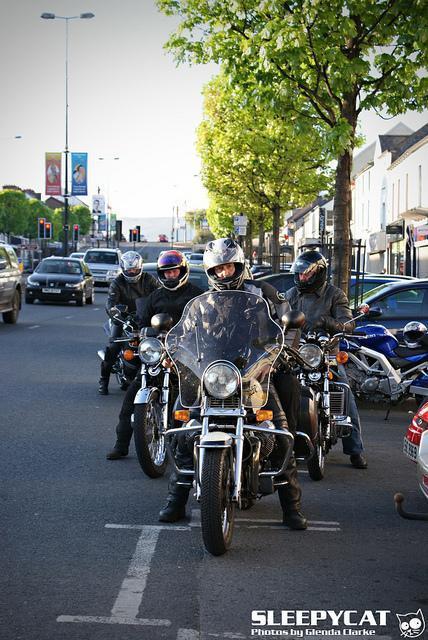How many of the helmets are completely covered without showing the face?
Give a very brief answer. 0. How many plastic face shields are on the motorcycles?
Give a very brief answer. 1. How many cars are there?
Give a very brief answer. 2. How many people can be seen?
Give a very brief answer. 4. How many motorcycles can be seen?
Give a very brief answer. 4. 